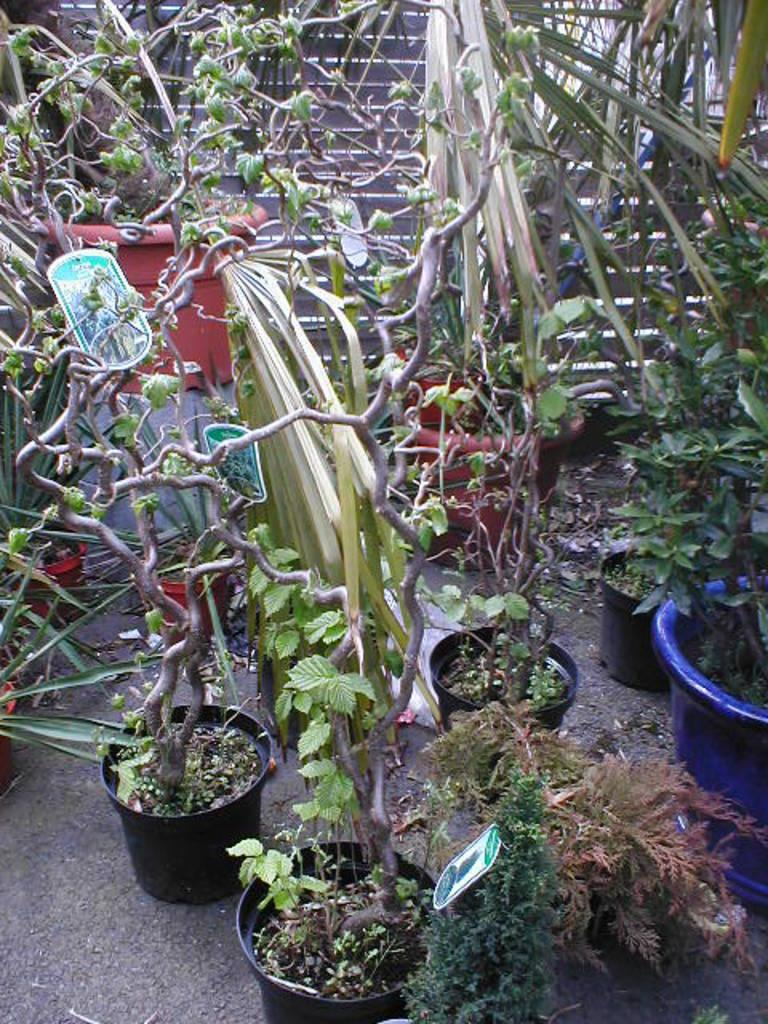Where was the picture taken? The picture was clicked outside. What can be seen in the foreground of the image? There are potted plants in the foreground. What is the main feature in the center of the image? There is a staircase in the center of the image. What else can be seen in the center of the image besides the staircase? There are other objects visible in the center of the image. How many plastic dogs are visible in the image? There are no plastic dogs present in the image. 